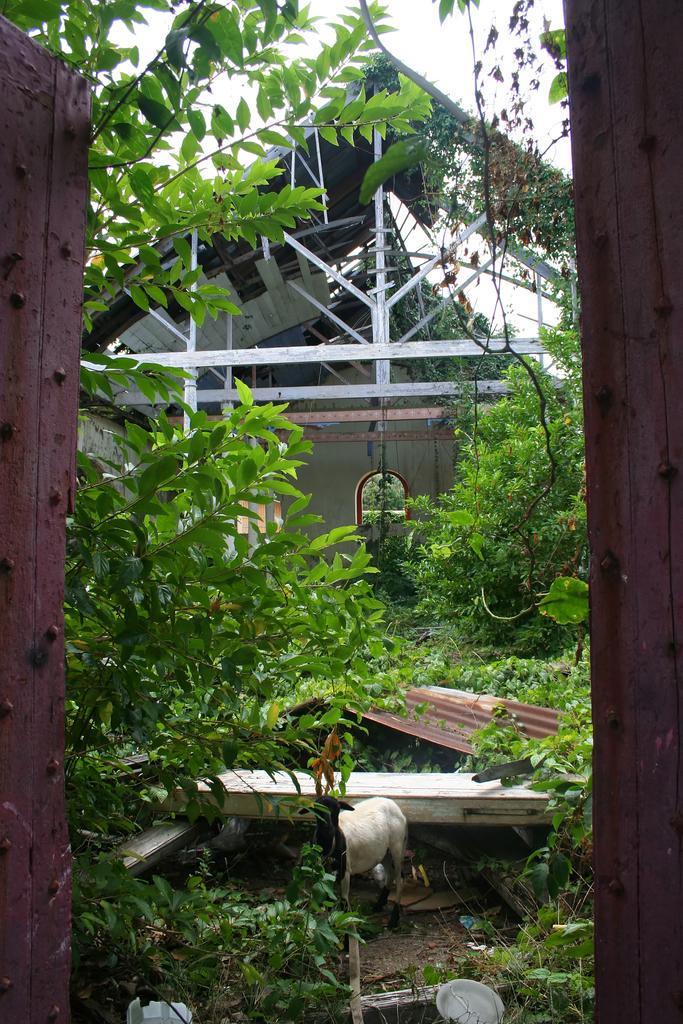How would you summarize this image in a sentence or two? In front of the image there is a door. There is a goat. There are plants, trees and a few other objects. In the background of the image there is a metal shed. At the top of the image there is sky. 